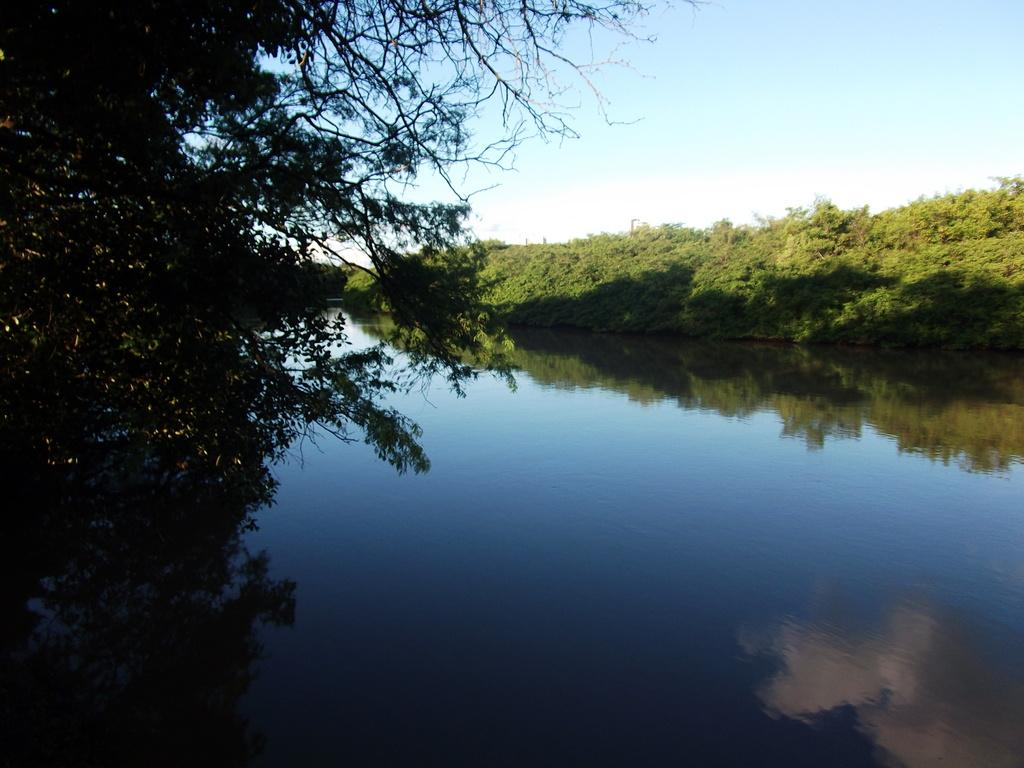What is visible in the image? There is water visible in the image. What can be seen on both sides of the water? There are trees on both sides of the water. What is visible in the background of the image? The sky is visible in the background of the image. Where is the pin located in the image? There is no pin present in the image. What type of hydrant can be seen near the water in the image? There is no hydrant present in the image. 